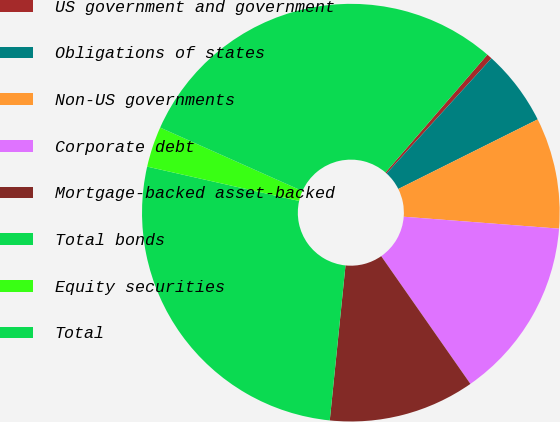<chart> <loc_0><loc_0><loc_500><loc_500><pie_chart><fcel>US government and government<fcel>Obligations of states<fcel>Non-US governments<fcel>Corporate debt<fcel>Mortgage-backed asset-backed<fcel>Total bonds<fcel>Equity securities<fcel>Total<nl><fcel>0.42%<fcel>5.87%<fcel>8.59%<fcel>14.08%<fcel>11.31%<fcel>26.93%<fcel>3.14%<fcel>29.66%<nl></chart> 